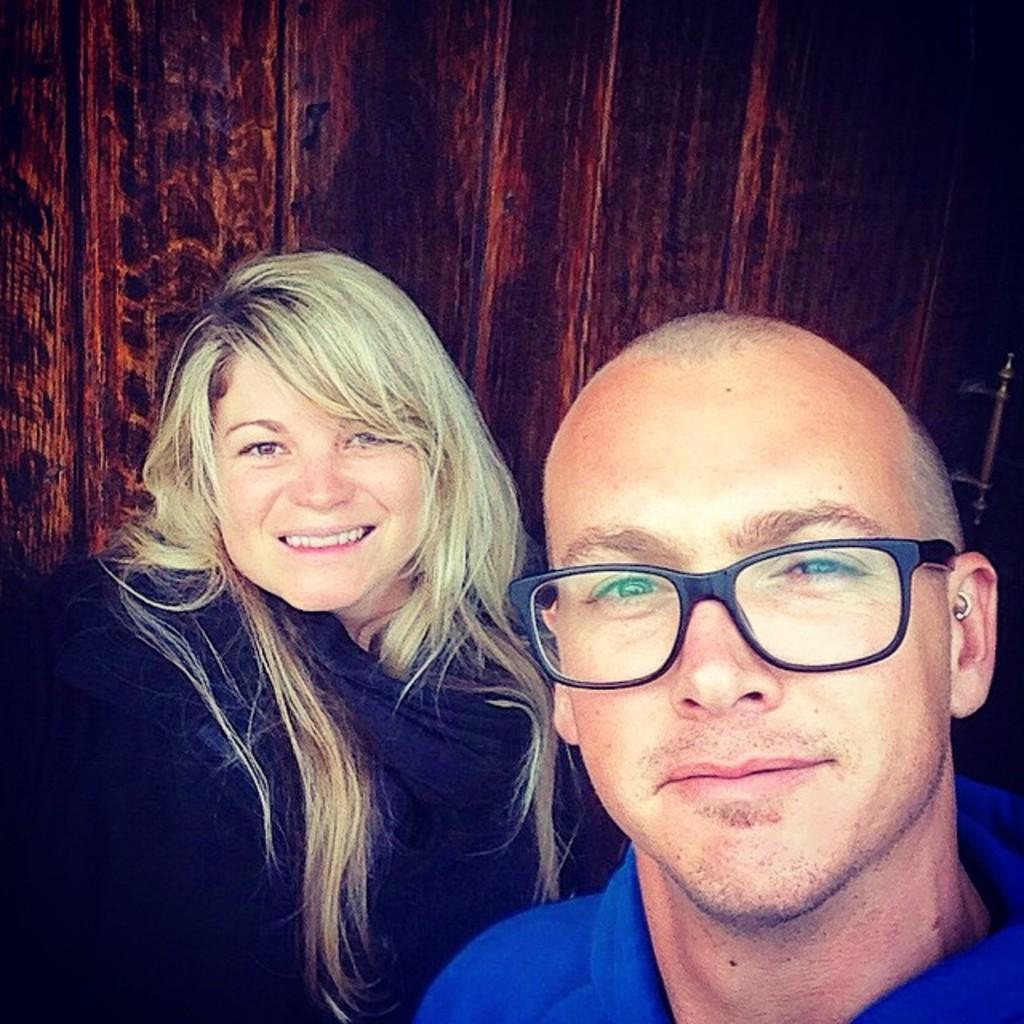Where was the image taken? The image was taken indoors. What can be seen in the background of the image? There is a door in the background of the image. Who are the people in the image? There is a man and a woman in the middle of the image. What expressions do the man and the woman have? Both the man and the woman are smiling. How many bottles of water can be seen on the window sill in the image? There is no window sill or bottle of water present in the image. What type of family is depicted in the image? The image does not depict a family; it features a man and a woman who are not necessarily related. 